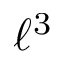<formula> <loc_0><loc_0><loc_500><loc_500>\ell ^ { 3 }</formula> 